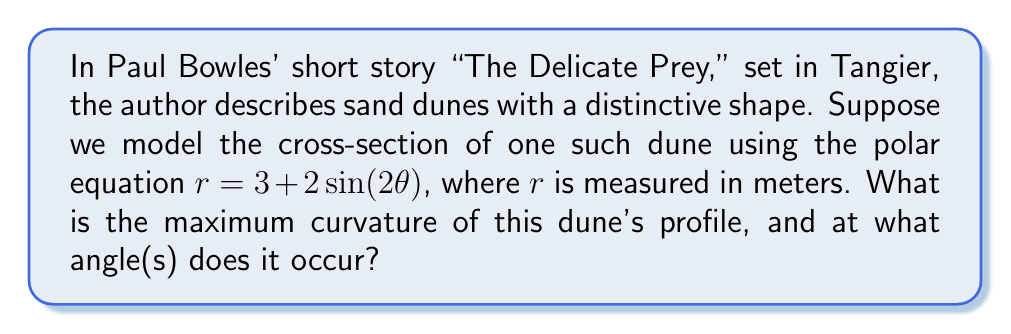Provide a solution to this math problem. To find the maximum curvature of the dune's profile, we need to follow these steps:

1) The curvature $\kappa$ in polar coordinates is given by:

   $$\kappa = \frac{|r^2 + 2(r')^2 - rr''|}{(r^2 + (r')^2)^{3/2}}$$

2) We need to find $r'$ and $r''$:
   
   $r = 3 + 2\sin(2\theta)$
   $r' = 4\cos(2\theta)$
   $r'' = -8\sin(2\theta)$

3) Substitute these into the curvature formula:

   $$\kappa = \frac{|(3 + 2\sin(2\theta))^2 + 2(4\cos(2\theta))^2 - (3 + 2\sin(2\theta))(-8\sin(2\theta))|}{((3 + 2\sin(2\theta))^2 + (4\cos(2\theta))^2)^{3/2}}$$

4) Simplify:

   $$\kappa = \frac{|9 + 12\sin(2\theta) + 4\sin^2(2\theta) + 32\cos^2(2\theta) + 24\sin(2\theta) + 16\sin^2(2\theta)|}{(9 + 12\sin(2\theta) + 4\sin^2(2\theta) + 16\cos^2(2\theta))^{3/2}}$$

   $$\kappa = \frac{|41 + 36\sin(2\theta) + 20\sin^2(2\theta)|}{(25 + 12\sin(2\theta) + 4\sin^2(2\theta))^{3/2}}$$

5) To find the maximum curvature, we need to find where $\frac{d\kappa}{d\theta} = 0$. However, this leads to a complex equation. Instead, we can observe that the numerator will be largest when $\sin(2\theta) = 1$ or $\sin(2\theta) = -1$, which occurs at $\theta = \frac{\pi}{4}$ and $\theta = \frac{3\pi}{4}$ respectively.

6) Evaluating at $\theta = \frac{\pi}{4}$:

   $$\kappa = \frac{|41 + 36 + 20|}{(25 + 12 + 4)^{3/2}} = \frac{97}{41^{3/2}} \approx 0.3675$$

   At $\theta = \frac{3\pi}{4}$:

   $$\kappa = \frac{|41 - 36 + 20|}{(25 - 12 + 4)^{3/2}} = \frac{25}{17^{3/2}} \approx 0.3562$$

Therefore, the maximum curvature occurs at $\theta = \frac{\pi}{4}$ and $\theta = \frac{5\pi}{4}$ (due to symmetry).
Answer: The maximum curvature is $\frac{97}{41^{3/2}} \approx 0.3675$ m^(-1), occurring at $\theta = \frac{\pi}{4}$ and $\theta = \frac{5\pi}{4}$. 